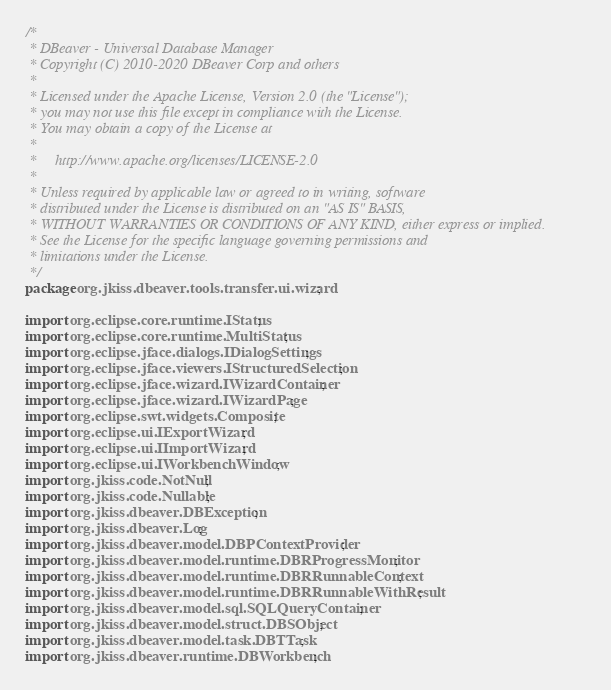<code> <loc_0><loc_0><loc_500><loc_500><_Java_>/*
 * DBeaver - Universal Database Manager
 * Copyright (C) 2010-2020 DBeaver Corp and others
 *
 * Licensed under the Apache License, Version 2.0 (the "License");
 * you may not use this file except in compliance with the License.
 * You may obtain a copy of the License at
 *
 *     http://www.apache.org/licenses/LICENSE-2.0
 *
 * Unless required by applicable law or agreed to in writing, software
 * distributed under the License is distributed on an "AS IS" BASIS,
 * WITHOUT WARRANTIES OR CONDITIONS OF ANY KIND, either express or implied.
 * See the License for the specific language governing permissions and
 * limitations under the License.
 */
package org.jkiss.dbeaver.tools.transfer.ui.wizard;

import org.eclipse.core.runtime.IStatus;
import org.eclipse.core.runtime.MultiStatus;
import org.eclipse.jface.dialogs.IDialogSettings;
import org.eclipse.jface.viewers.IStructuredSelection;
import org.eclipse.jface.wizard.IWizardContainer;
import org.eclipse.jface.wizard.IWizardPage;
import org.eclipse.swt.widgets.Composite;
import org.eclipse.ui.IExportWizard;
import org.eclipse.ui.IImportWizard;
import org.eclipse.ui.IWorkbenchWindow;
import org.jkiss.code.NotNull;
import org.jkiss.code.Nullable;
import org.jkiss.dbeaver.DBException;
import org.jkiss.dbeaver.Log;
import org.jkiss.dbeaver.model.DBPContextProvider;
import org.jkiss.dbeaver.model.runtime.DBRProgressMonitor;
import org.jkiss.dbeaver.model.runtime.DBRRunnableContext;
import org.jkiss.dbeaver.model.runtime.DBRRunnableWithResult;
import org.jkiss.dbeaver.model.sql.SQLQueryContainer;
import org.jkiss.dbeaver.model.struct.DBSObject;
import org.jkiss.dbeaver.model.task.DBTTask;
import org.jkiss.dbeaver.runtime.DBWorkbench;</code> 